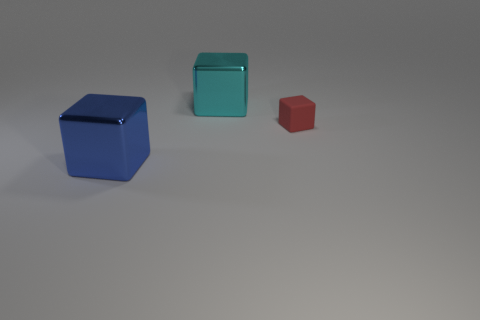How many large things are either blue cubes or cyan objects?
Offer a terse response. 2. Are there more tiny objects than large metallic cubes?
Make the answer very short. No. What size is the blue cube that is the same material as the cyan object?
Offer a terse response. Large. Is the size of the thing on the left side of the cyan shiny cube the same as the cube right of the big cyan shiny block?
Give a very brief answer. No. What number of things are either big blocks that are to the right of the blue shiny block or red cubes?
Keep it short and to the point. 2. Is the number of small yellow matte blocks less than the number of large blue blocks?
Your answer should be very brief. Yes. What shape is the object to the right of the large cube that is behind the blue shiny block that is in front of the tiny block?
Offer a very short reply. Cube. Is there a metal cylinder?
Your answer should be compact. No. There is a blue metal thing; does it have the same size as the object that is right of the cyan thing?
Your response must be concise. No. Are there any red things behind the metallic cube to the right of the large blue shiny cube?
Provide a succinct answer. No. 